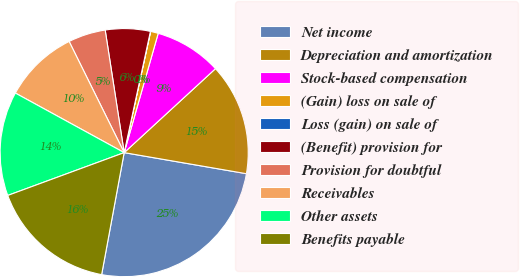<chart> <loc_0><loc_0><loc_500><loc_500><pie_chart><fcel>Net income<fcel>Depreciation and amortization<fcel>Stock-based compensation<fcel>(Gain) loss on sale of<fcel>Loss (gain) on sale of<fcel>(Benefit) provision for<fcel>Provision for doubtful<fcel>Receivables<fcel>Other assets<fcel>Benefits payable<nl><fcel>25.19%<fcel>14.55%<fcel>8.74%<fcel>1.0%<fcel>0.03%<fcel>5.84%<fcel>4.87%<fcel>9.71%<fcel>13.58%<fcel>16.48%<nl></chart> 